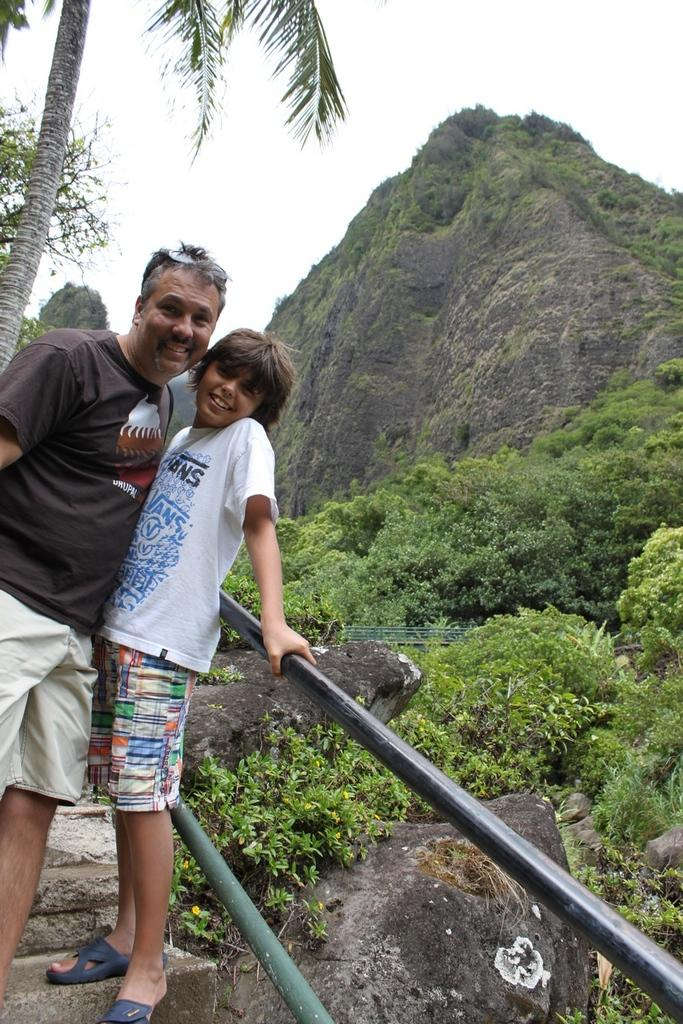How many persons are in the image? There are two persons standing on the steps on the left side of the image. What can be seen on the steps? The persons are standing on the steps. What is present near the steps? A: There are railings in the image. What can be seen in the background of the image? There are trees, plants, rocks, a mountain, and the sky visible in the background of the image. What type of reaction does the frog have when it sees the boot in the image? There is no frog or boot present in the image, so it is not possible to determine any reaction. 